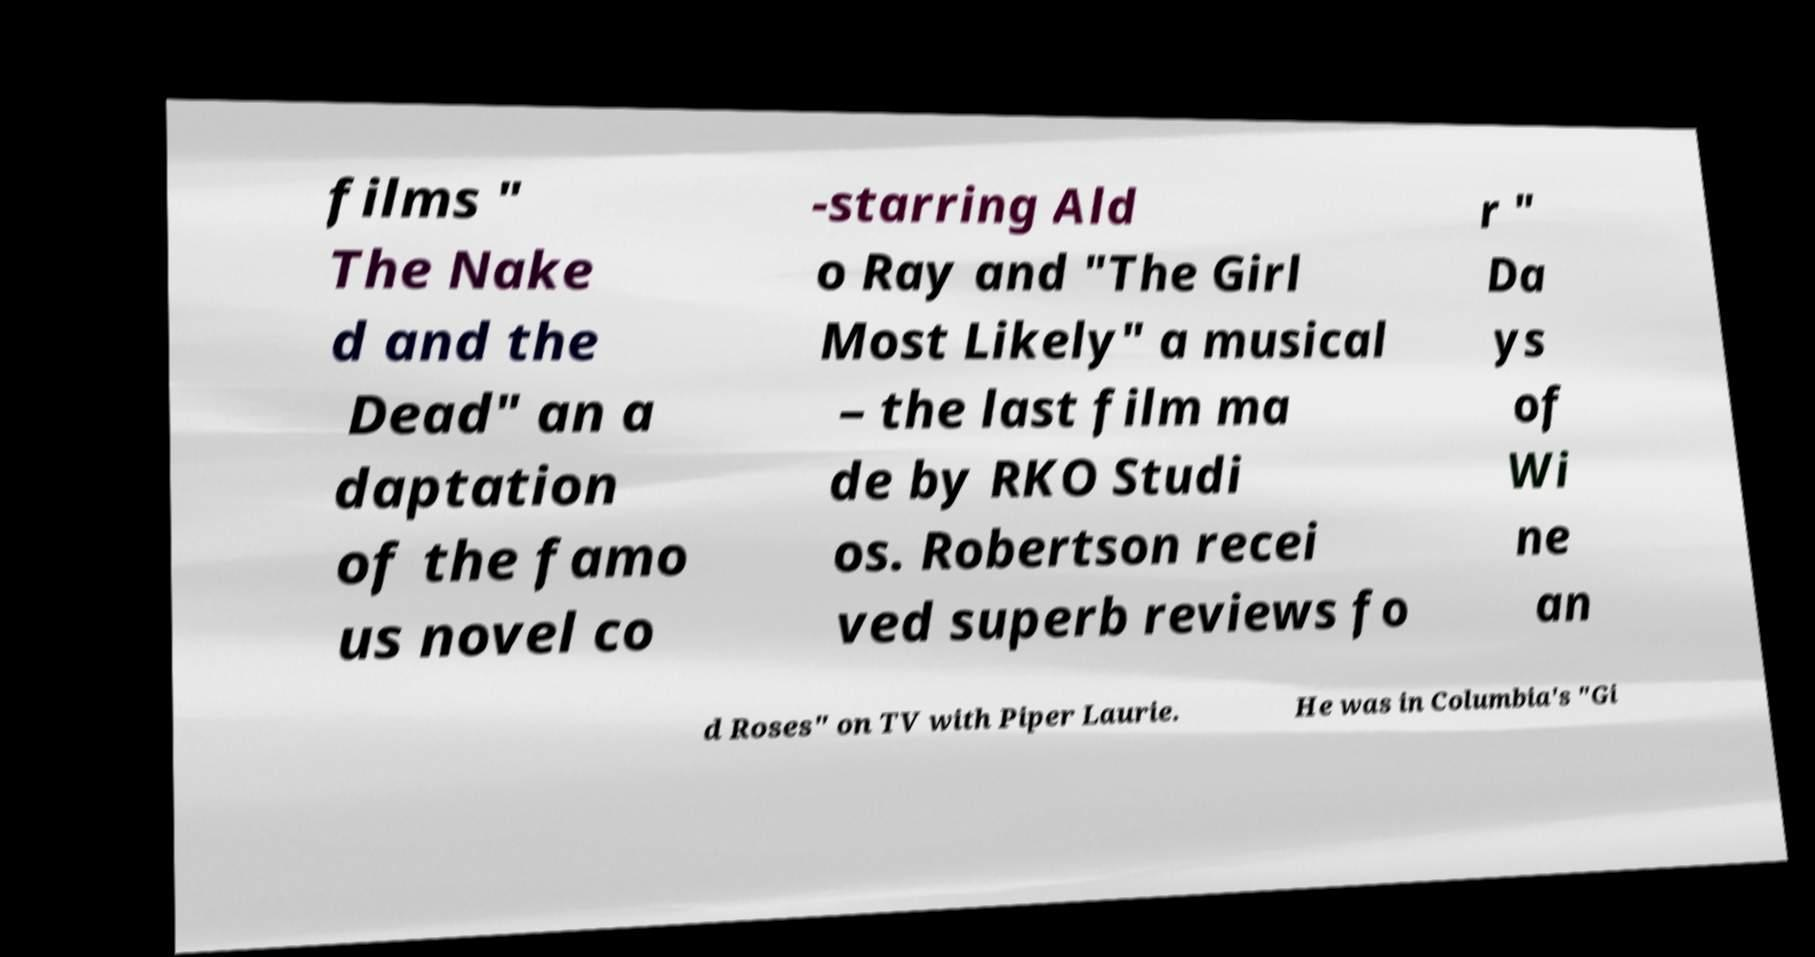Please identify and transcribe the text found in this image. films " The Nake d and the Dead" an a daptation of the famo us novel co -starring Ald o Ray and "The Girl Most Likely" a musical – the last film ma de by RKO Studi os. Robertson recei ved superb reviews fo r " Da ys of Wi ne an d Roses" on TV with Piper Laurie. He was in Columbia's "Gi 